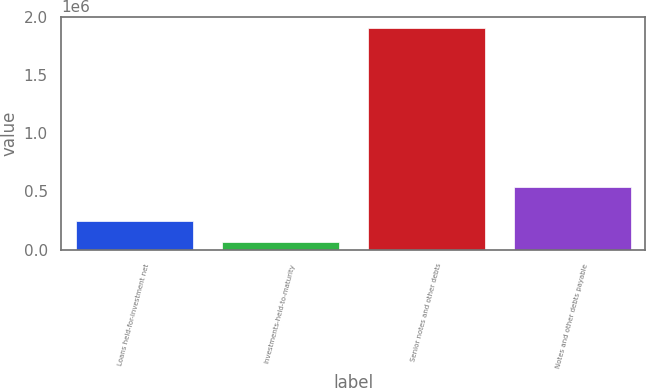Convert chart to OTSL. <chart><loc_0><loc_0><loc_500><loc_500><bar_chart><fcel>Loans held-for-investment net<fcel>Investments-held-to-maturity<fcel>Senior notes and other debts<fcel>Notes and other debts payable<nl><fcel>245965<fcel>61572<fcel>1.9055e+06<fcel>541437<nl></chart> 